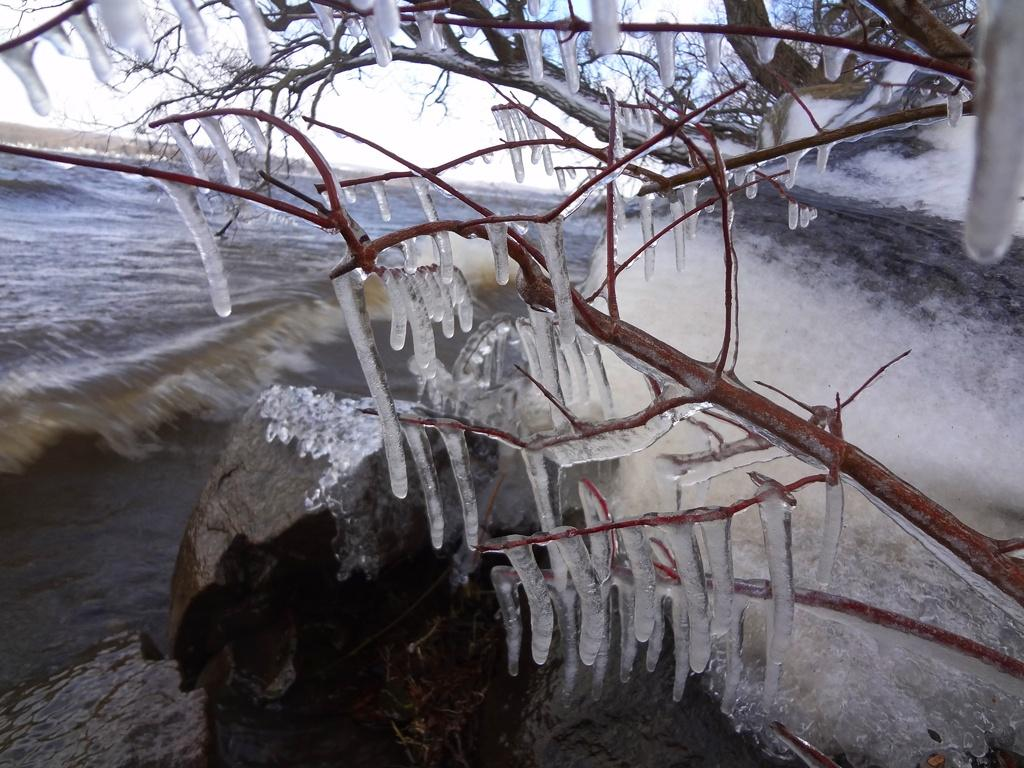What is frozen on the tree in the foreground of the image? There is water frozen on a tree in the foreground of the image. What can be seen in the background of the image? There is a stone water feature in the background of the image. What is visible in the sky in the background of the image? The sky is visible in the background of the image. What type of butter is being spread on the pump in the image? There is no butter or pump present in the image. What noise can be heard coming from the stone water feature in the image? The image does not provide any information about sounds or noises, so it cannot be determined what noise might be coming from the stone water feature. 